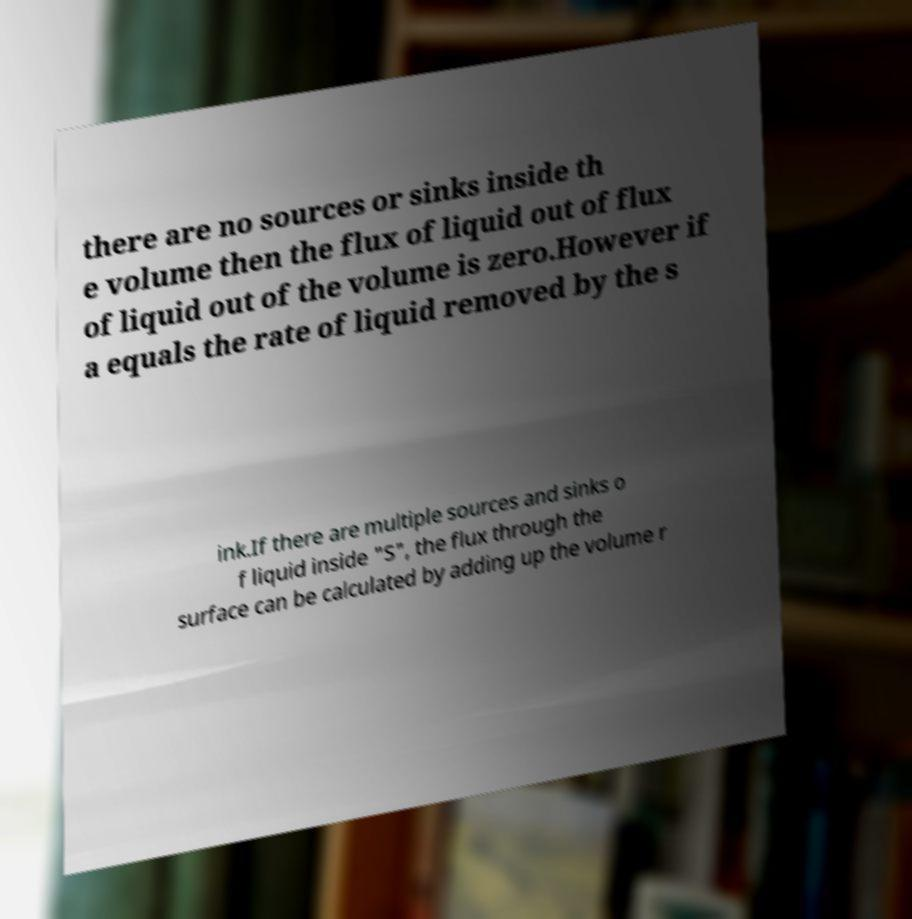For documentation purposes, I need the text within this image transcribed. Could you provide that? there are no sources or sinks inside th e volume then the flux of liquid out of flux of liquid out of the volume is zero.However if a equals the rate of liquid removed by the s ink.If there are multiple sources and sinks o f liquid inside "S", the flux through the surface can be calculated by adding up the volume r 